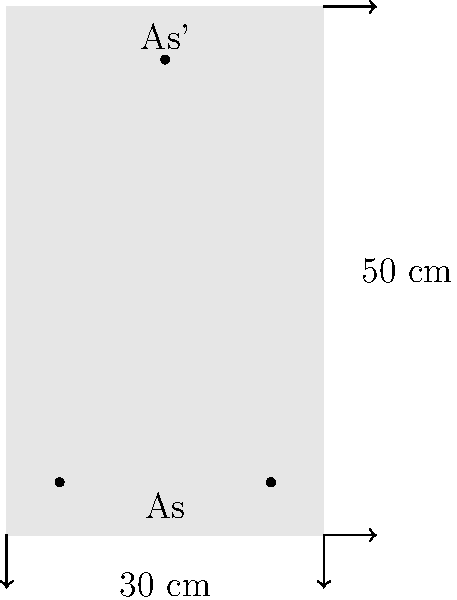As an educational technology expert specializing in 3D printing, you're designing a virtual reality simulation for civil engineering students. The simulation focuses on reinforced concrete beam design. Given a rectangular beam cross-section of 30 cm width and 50 cm depth, with tension reinforcement $A_s$ at the bottom and compression reinforcement $A_s'$ at the top, calculate the required area of tension reinforcement $A_s$ to resist a design moment of 300 kNm. Assume the following:

- Concrete strength: $f_{ck} = 30$ MPa
- Steel yield strength: $f_y = 500$ MPa
- Effective depth: $d = 45$ cm
- $\beta_1 = 0.85$ (stress block factor)
- $A_s' = 0.5A_s$

How would you determine the required area of tension reinforcement $A_s$ in cm²? To solve this problem, we'll follow these steps:

1) First, we need to calculate the balanced reinforcement ratio $\rho_b$:
   $$\rho_b = 0.85\beta_1 \frac{f_{ck}}{f_y} \frac{600}{600+f_y} = 0.85 \cdot 0.85 \cdot \frac{30}{500} \cdot \frac{600}{1100} = 0.0280$$

2) Assume the section is tension-controlled with $\rho < \rho_b$. We'll verify this later.

3) Calculate the design strength of materials:
   $$f_{cd} = 0.85f_{ck} = 0.85 \cdot 30 = 25.5 \text{ MPa}$$
   $$f_{yd} = f_y = 500 \text{ MPa}$$

4) Using the quadratic equation for moment capacity:
   $$M_u = 0.85f_{cd}bx(d-0.5x) + f_{yd}A_s'(d-d')$$

   Where $x$ is the neutral axis depth, $b$ is the beam width, and $d'$ is the cover to the compression steel (assume 5 cm).

5) Substituting known values and $A_s' = 0.5A_s$:
   $$300 \cdot 10^6 = 0.85 \cdot 25.5 \cdot 300 \cdot x(450-0.5x) + 500 \cdot 0.5A_s(450-50)$$

6) Simplify:
   $$300 \cdot 10^6 = 6502.5x(450-0.5x) + 100000A_s$$

7) From equilibrium of forces:
   $$0.85f_{cd}bx + f_{yd}A_s' = f_{yd}A_s$$
   $$6502.5x + 250A_s = 500A_s$$
   $$A_s = \frac{6502.5x}{250} = 26.01x$$

8) Substitute this into the moment equation:
   $$300 \cdot 10^6 = 6502.5x(450-0.5x) + 2601000x$$

9) Solve this quadratic equation:
   $$3251.25x^2 - 2925125x + 300 \cdot 10^6 = 0$$
   $$x \approx 114.7 \text{ mm}$$

10) Calculate $A_s$:
    $$A_s = 26.01 \cdot 114.7 = 2983 \text{ mm}^2 = 29.83 \text{ cm}^2$$

11) Verify tension-controlled assumption:
    $$\rho = \frac{A_s}{bd} = \frac{2983}{300 \cdot 450} = 0.0221 < \rho_b = 0.0280$$
    The assumption is correct.
Answer: 29.83 cm² 